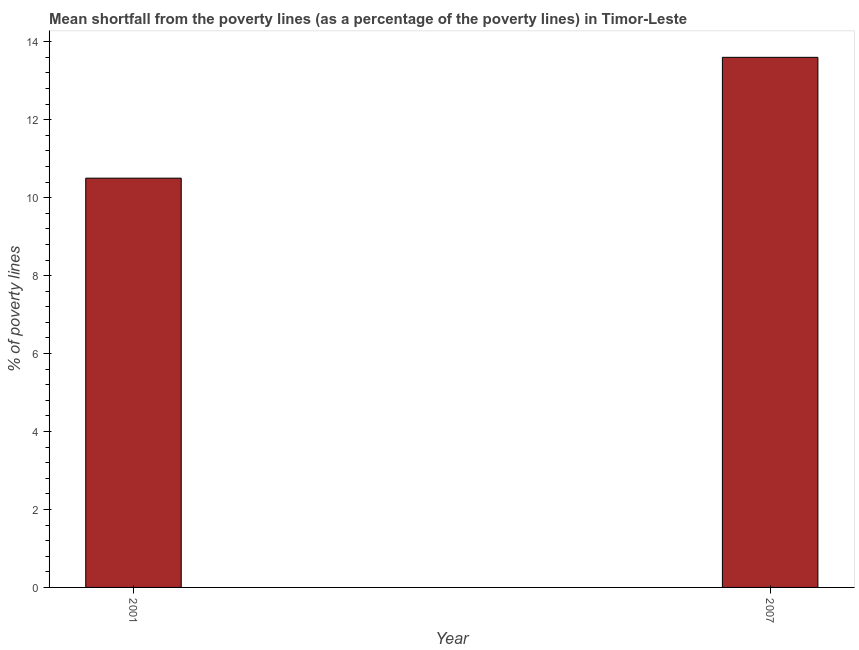What is the title of the graph?
Your answer should be compact. Mean shortfall from the poverty lines (as a percentage of the poverty lines) in Timor-Leste. What is the label or title of the Y-axis?
Your answer should be compact. % of poverty lines. Across all years, what is the maximum poverty gap at national poverty lines?
Provide a short and direct response. 13.6. Across all years, what is the minimum poverty gap at national poverty lines?
Provide a succinct answer. 10.5. In which year was the poverty gap at national poverty lines maximum?
Provide a succinct answer. 2007. In which year was the poverty gap at national poverty lines minimum?
Give a very brief answer. 2001. What is the sum of the poverty gap at national poverty lines?
Offer a very short reply. 24.1. What is the difference between the poverty gap at national poverty lines in 2001 and 2007?
Offer a very short reply. -3.1. What is the average poverty gap at national poverty lines per year?
Offer a terse response. 12.05. What is the median poverty gap at national poverty lines?
Give a very brief answer. 12.05. Do a majority of the years between 2001 and 2007 (inclusive) have poverty gap at national poverty lines greater than 6.4 %?
Ensure brevity in your answer.  Yes. What is the ratio of the poverty gap at national poverty lines in 2001 to that in 2007?
Make the answer very short. 0.77. In how many years, is the poverty gap at national poverty lines greater than the average poverty gap at national poverty lines taken over all years?
Provide a short and direct response. 1. Are all the bars in the graph horizontal?
Provide a short and direct response. No. How many years are there in the graph?
Your answer should be very brief. 2. What is the % of poverty lines of 2001?
Ensure brevity in your answer.  10.5. What is the % of poverty lines of 2007?
Keep it short and to the point. 13.6. What is the ratio of the % of poverty lines in 2001 to that in 2007?
Give a very brief answer. 0.77. 